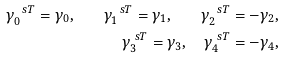Convert formula to latex. <formula><loc_0><loc_0><loc_500><loc_500>\gamma ^ { \ s T } _ { 0 } = \gamma _ { 0 } , \quad \gamma ^ { \ s T } _ { 1 } = \gamma _ { 1 } , \quad \gamma ^ { \ s T } _ { 2 } = - \gamma _ { 2 } , \\ \gamma ^ { \ s T } _ { 3 } = \gamma _ { 3 } , \quad \gamma ^ { \ s T } _ { 4 } = - \gamma _ { 4 } ,</formula> 